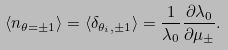<formula> <loc_0><loc_0><loc_500><loc_500>\left < n _ { \theta = \pm 1 } \right > = \left < \delta _ { \theta _ { i } , \pm 1 } \right > = \frac { 1 } { \lambda _ { 0 } } \frac { \partial \lambda _ { 0 } } { \partial \mu _ { \pm } } .</formula> 